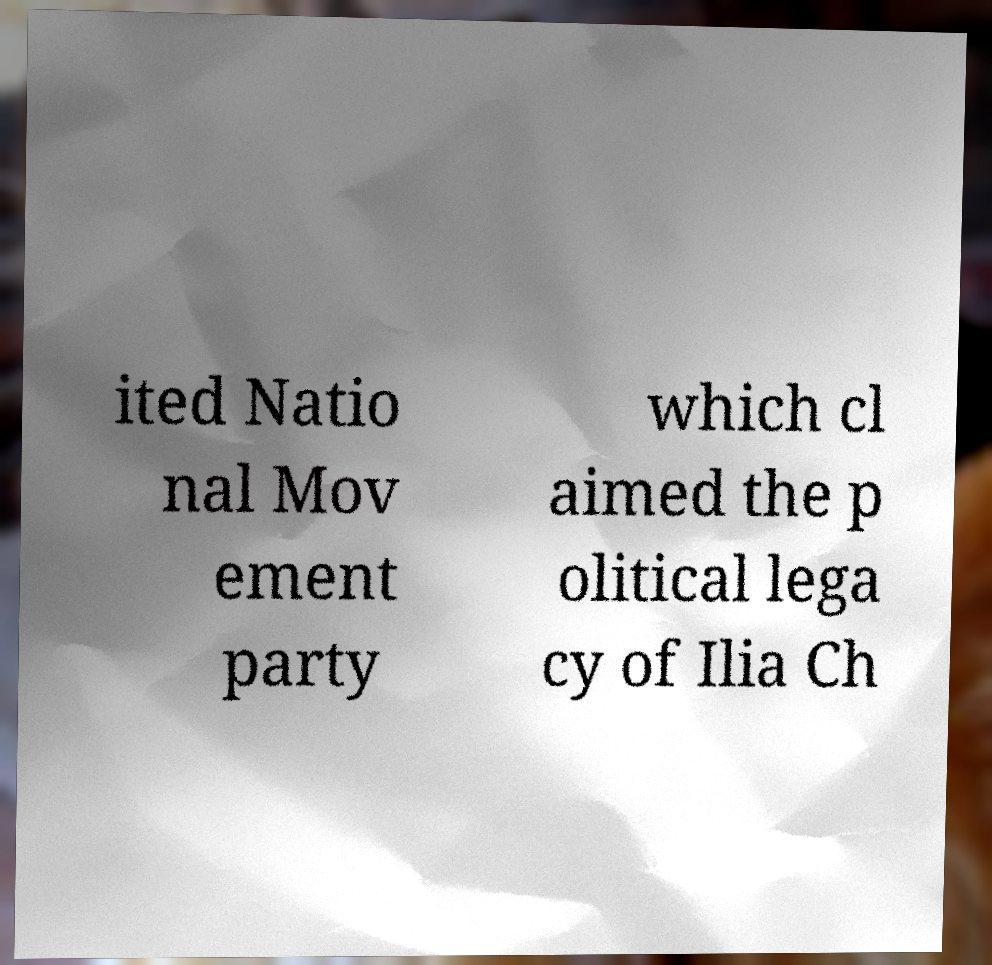For documentation purposes, I need the text within this image transcribed. Could you provide that? ited Natio nal Mov ement party which cl aimed the p olitical lega cy of Ilia Ch 